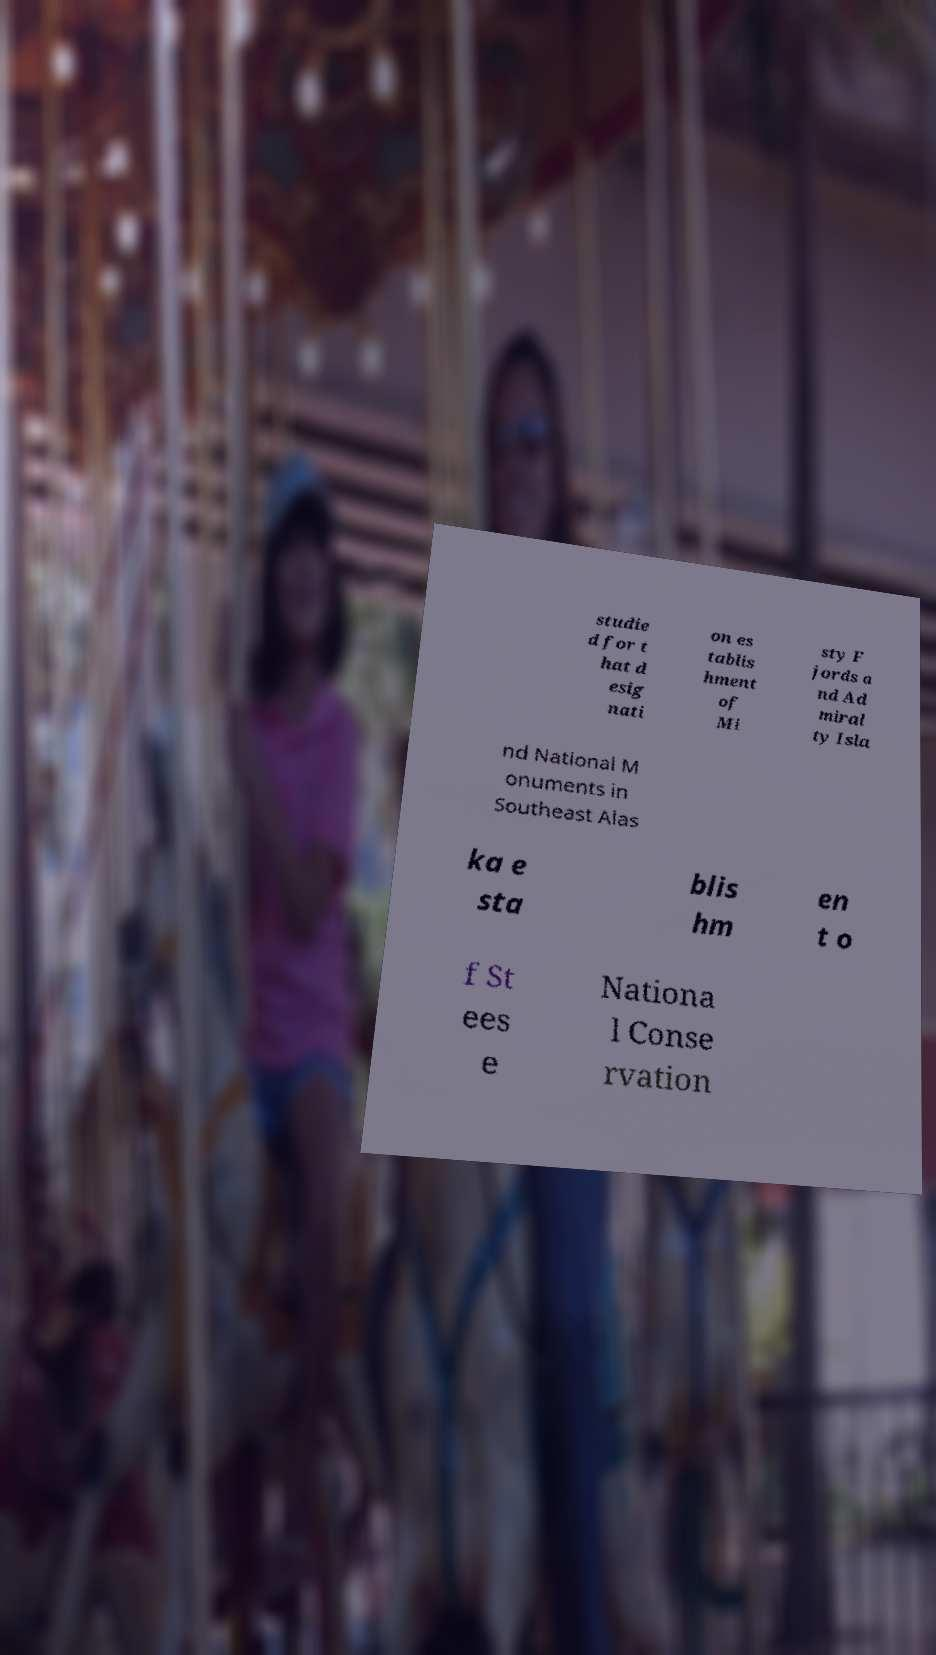Please identify and transcribe the text found in this image. studie d for t hat d esig nati on es tablis hment of Mi sty F jords a nd Ad miral ty Isla nd National M onuments in Southeast Alas ka e sta blis hm en t o f St ees e Nationa l Conse rvation 